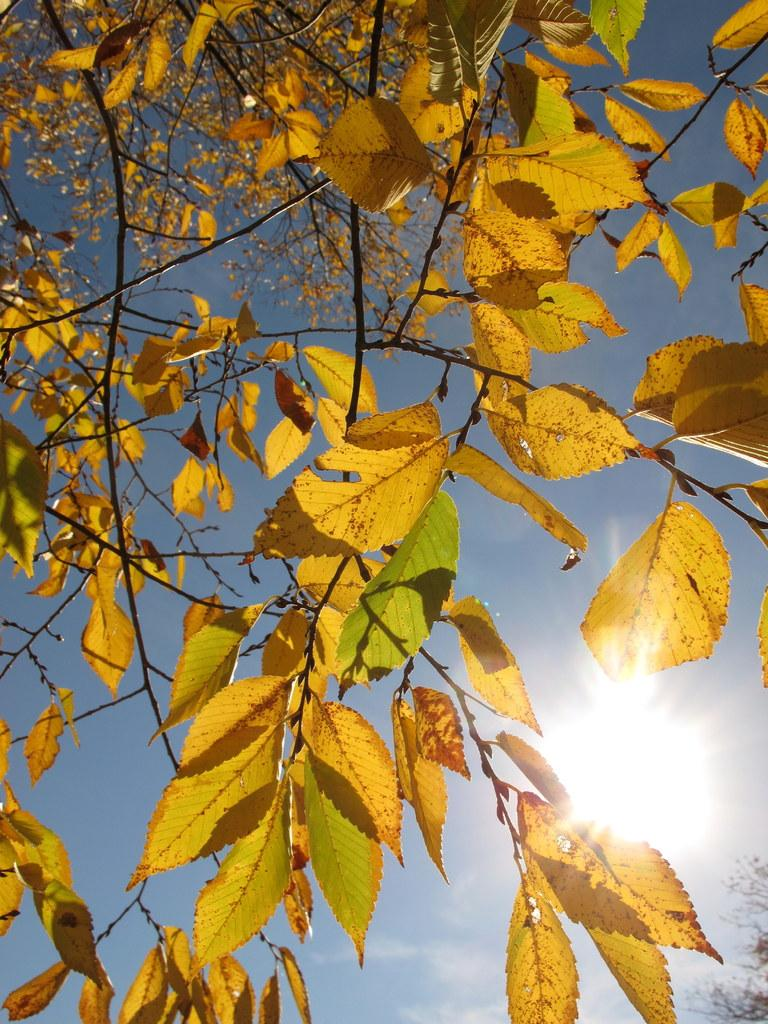What type of vegetation is present in the image? There are leaves in the image. What is visible in the background of the image? There is a sky visible in the background of the image. Can the sun be seen in the sky in the background of the image? Yes, the sun is observable in the sky in the background of the image. What type of record is being played in the image? There is no record present in the image. Can you see any toes in the image? There is no reference to toes in the image. 